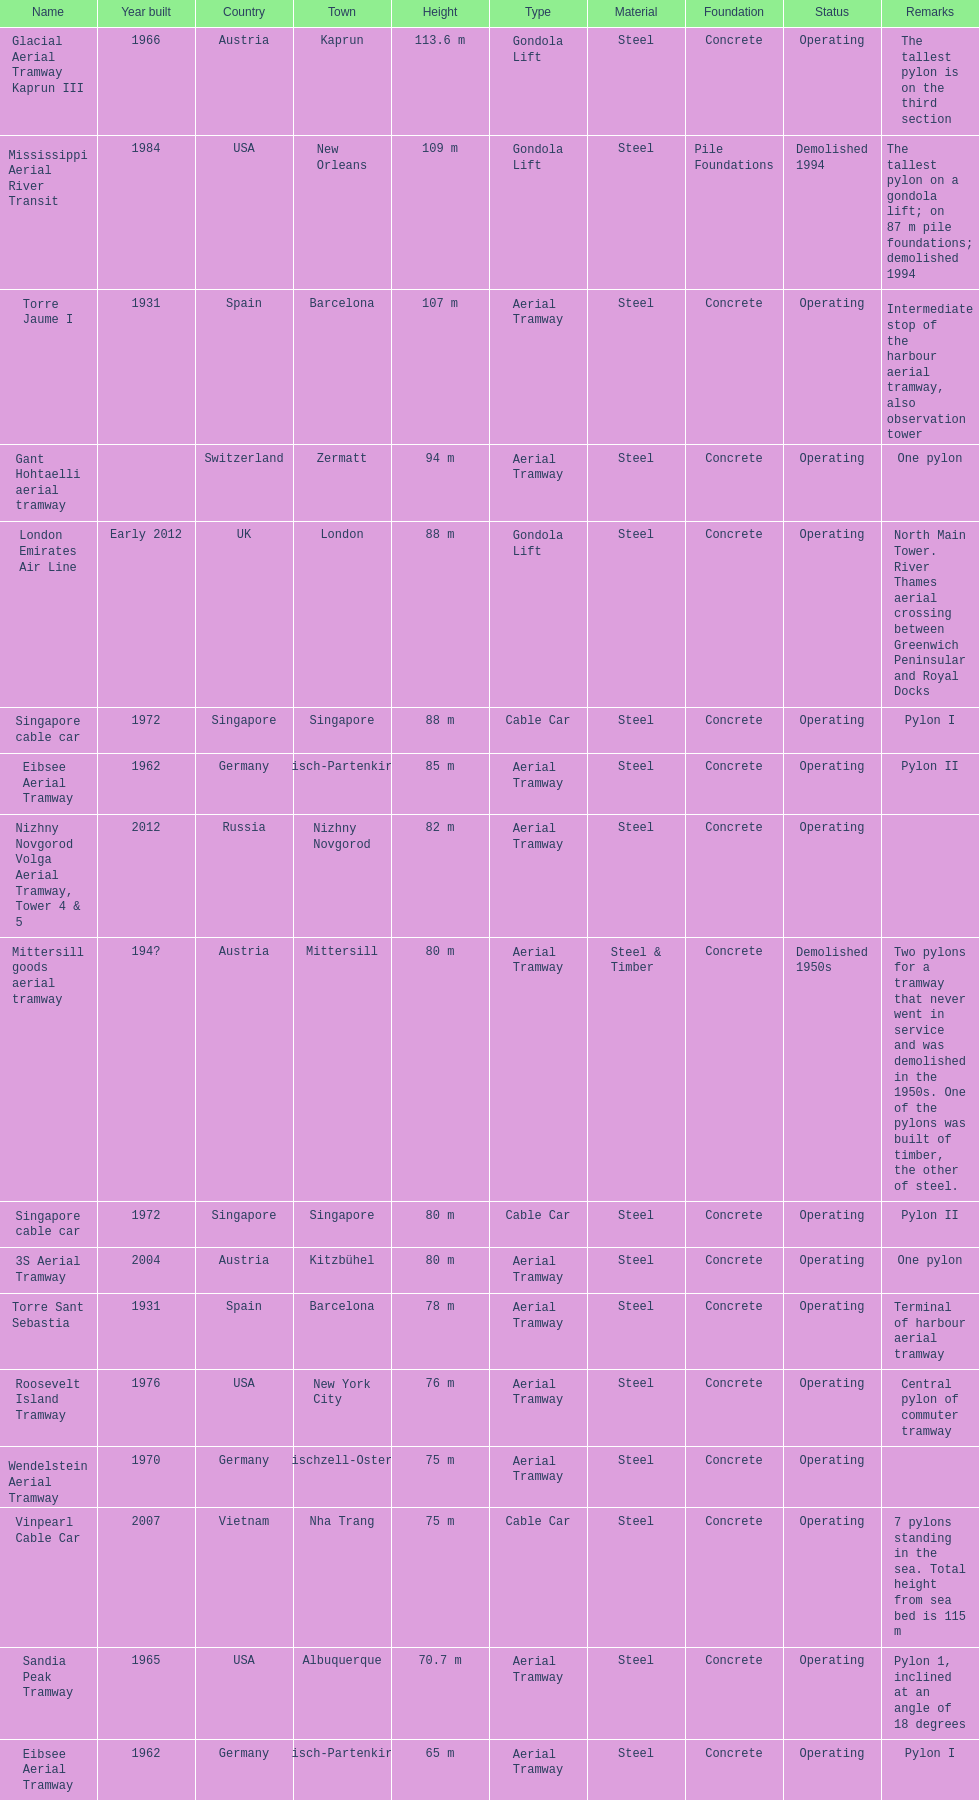Which pylon has the shortest height? Eibsee Aerial Tramway. 